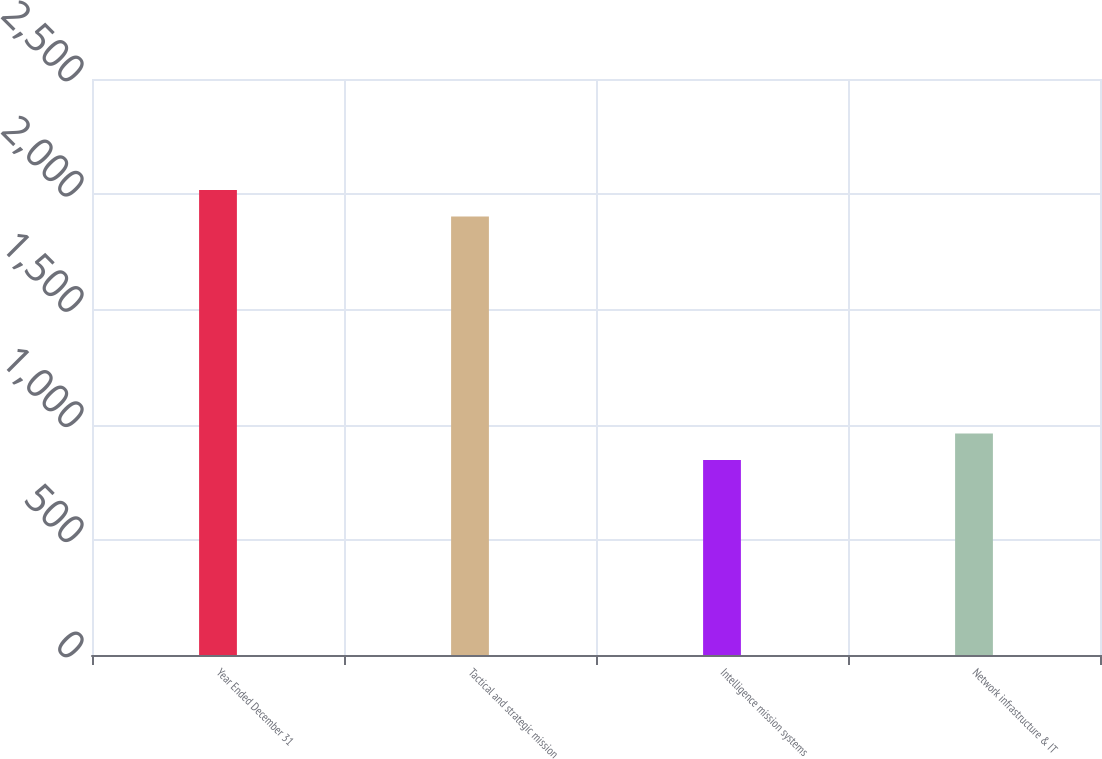Convert chart. <chart><loc_0><loc_0><loc_500><loc_500><bar_chart><fcel>Year Ended December 31<fcel>Tactical and strategic mission<fcel>Intelligence mission systems<fcel>Network infrastructure & IT<nl><fcel>2018.6<fcel>1903<fcel>846<fcel>961.6<nl></chart> 